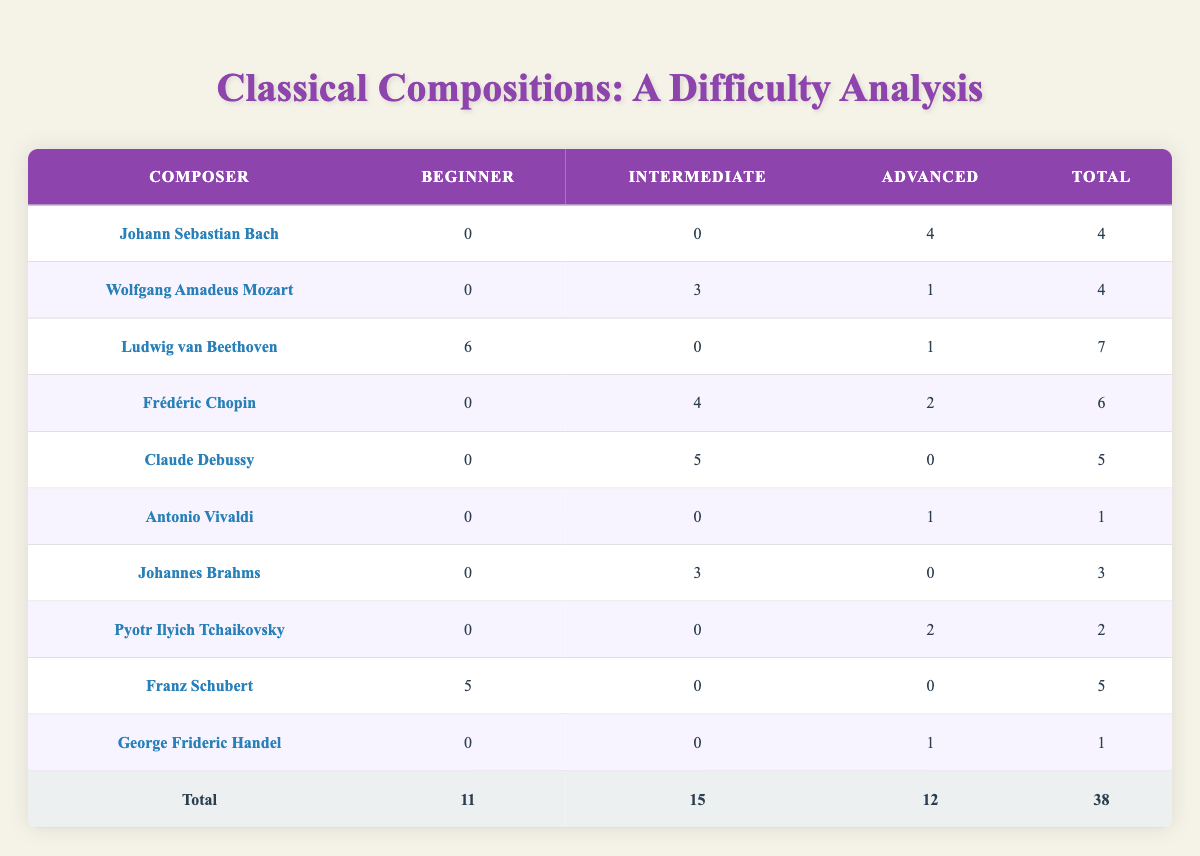What is the total number of sheet music pieces that fall under the Beginner category? To find the total number of pieces that are classified as Beginner, we sum the values in the Beginner column: 0 (Bach) + 0 (Mozart) + 6 (Beethoven) + 0 (Chopin) + 0 (Debussy) + 0 (Vivaldi) + 0 (Brahms) + 0 (Tchaikovsky) + 5 (Schubert) + 0 (Handel) = 11.
Answer: 11 Which composer has the highest number of Intermediate pieces? Looking at the Intermediate column, we see Wolfgang Amadeus Mozart has 3, Frédéric Chopin has 4, and Claude Debussy has 5. Therefore, Claude Debussy has the highest number of Intermediate pieces.
Answer: Claude Debussy How many total pieces were created by Ludwig van Beethoven? To find the total pieces composed by Ludwig van Beethoven, we sum his pieces across all difficulty levels: 6 (Beginner) + 0 (Intermediate) + 1 (Advanced) = 7.
Answer: 7 Is there any composer that has only Beginner pieces? Checking the table, Franz Schubert is the only composer with 5 Beginner pieces and no other categories, thus the answer is yes.
Answer: Yes What is the average number of Advanced pieces across all composers? To find the average of Advanced pieces, we first sum the Advanced column values: 4 (Bach) + 1 (Mozart) + 1 (Beethoven) + 2 (Chopin) + 0 (Debussy) + 1 (Vivaldi) + 0 (Brahms) + 2 (Tchaikovsky) + 0 (Schubert) + 1 (Handel) = 12. There are 10 composers in total, so the average is 12/10 = 1.2.
Answer: 1.2 Which difficulty level has the least number of total pieces? Adding up the total for each difficulty level gives us: 11 (Beginner) + 15 (Intermediate) + 12 (Advanced) = 38. The least is Advanced with 12 pieces.
Answer: Advanced How many more Intermediate pieces are there compared to Advanced pieces? The total for Intermediate is 15, and for Advanced is 12. The difference is 15 - 12 = 3, meaning there are 3 more Intermediate pieces compared to Advanced.
Answer: 3 What percentage of Tchaikovsky's total pieces are Advanced? Tchaikovsky has 2 Advanced pieces and the total number of his pieces is also 2 (0 Intermediate, 2 Advanced). The percentage is (2/2)*100 = 100%.
Answer: 100% Is Frédéric Chopin the only composer with both Intermediate and Advanced pieces? Checking the data, multiple composers (Chopin, Bach, Mozart) have Intermediate and Advanced pieces. Thus, the statement is false.
Answer: No 